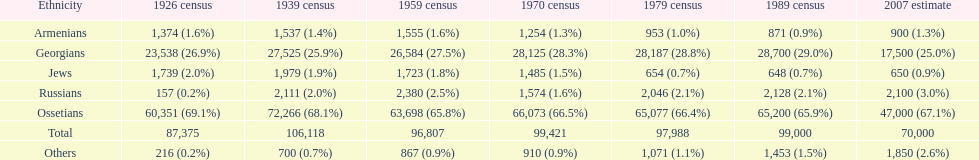What ethnicity is at the top? Ossetians. 